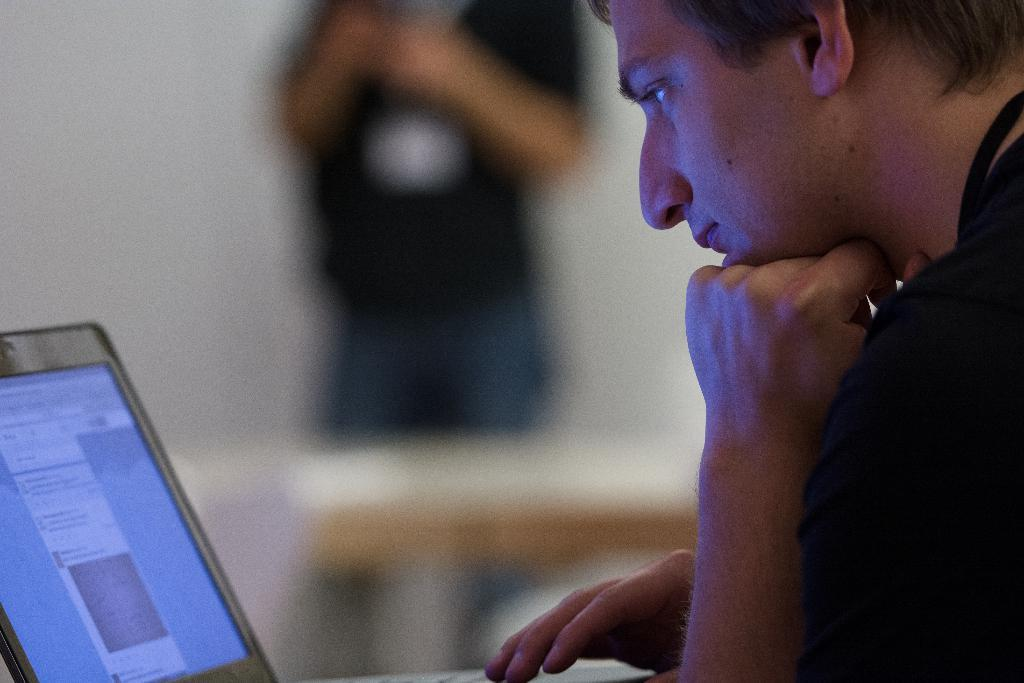What is the person in the image doing? The person is looking into a laptop. What object is present in the image that the person might be using? There is a table in the image that the person might be using. Can you describe the background of the image? There is a person standing in the background of the image. What type of cloud can be seen in the image? There is no cloud present in the image. What color is the coat worn by the person in the image? There is no coat visible in the image; the person is looking into a laptop. 